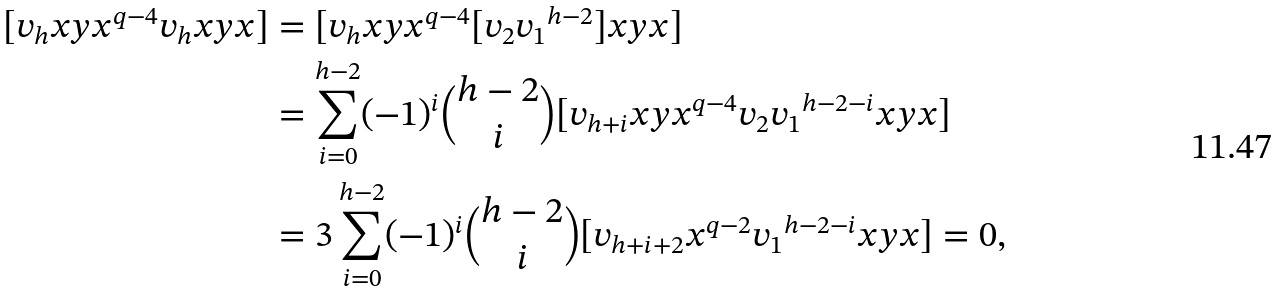<formula> <loc_0><loc_0><loc_500><loc_500>[ v _ { h } x y x ^ { q - 4 } v _ { h } x y x ] & = [ v _ { h } x y x ^ { q - 4 } [ v _ { 2 } { v _ { 1 } } ^ { h - 2 } ] x y x ] \\ & = \sum _ { i = 0 } ^ { h - 2 } ( - 1 ) ^ { i } \binom { h - 2 } { i } [ v _ { h + i } x y x ^ { q - 4 } v _ { 2 } { v _ { 1 } } ^ { h - 2 - i } x y x ] \\ & = 3 \sum _ { i = 0 } ^ { h - 2 } ( - 1 ) ^ { i } \binom { h - 2 } { i } [ v _ { h + i + 2 } x ^ { q - 2 } { v _ { 1 } } ^ { h - 2 - i } x y x ] = 0 ,</formula> 